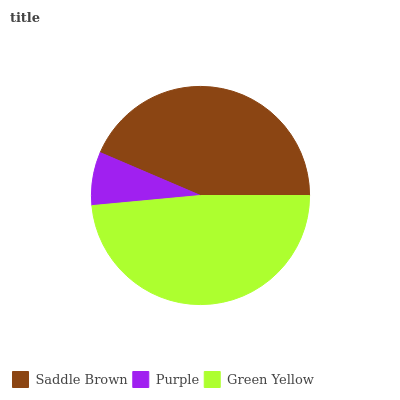Is Purple the minimum?
Answer yes or no. Yes. Is Green Yellow the maximum?
Answer yes or no. Yes. Is Green Yellow the minimum?
Answer yes or no. No. Is Purple the maximum?
Answer yes or no. No. Is Green Yellow greater than Purple?
Answer yes or no. Yes. Is Purple less than Green Yellow?
Answer yes or no. Yes. Is Purple greater than Green Yellow?
Answer yes or no. No. Is Green Yellow less than Purple?
Answer yes or no. No. Is Saddle Brown the high median?
Answer yes or no. Yes. Is Saddle Brown the low median?
Answer yes or no. Yes. Is Green Yellow the high median?
Answer yes or no. No. Is Green Yellow the low median?
Answer yes or no. No. 